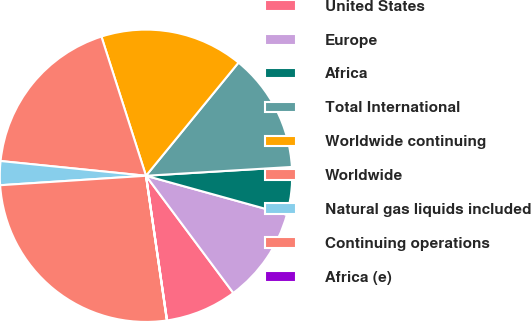Convert chart. <chart><loc_0><loc_0><loc_500><loc_500><pie_chart><fcel>United States<fcel>Europe<fcel>Africa<fcel>Total International<fcel>Worldwide continuing<fcel>Worldwide<fcel>Natural gas liquids included<fcel>Continuing operations<fcel>Africa (e)<nl><fcel>7.89%<fcel>10.51%<fcel>5.26%<fcel>13.13%<fcel>15.84%<fcel>18.46%<fcel>2.64%<fcel>26.25%<fcel>0.02%<nl></chart> 